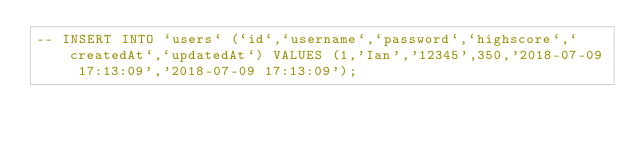Convert code to text. <code><loc_0><loc_0><loc_500><loc_500><_SQL_>-- INSERT INTO `users` (`id`,`username`,`password`,`highscore`,`createdAt`,`updatedAt`) VALUES (1,'Ian','12345',350,'2018-07-09 17:13:09','2018-07-09 17:13:09');</code> 